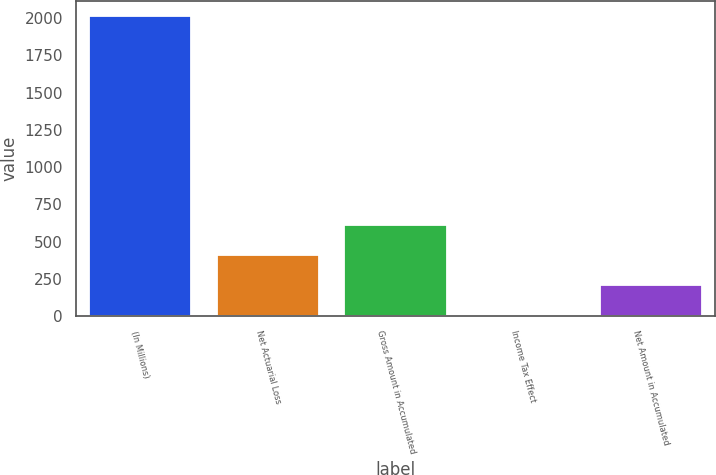Convert chart. <chart><loc_0><loc_0><loc_500><loc_500><bar_chart><fcel>(In Millions)<fcel>Net Actuarial Loss<fcel>Gross Amount in Accumulated<fcel>Income Tax Effect<fcel>Net Amount in Accumulated<nl><fcel>2016<fcel>408.56<fcel>609.49<fcel>6.7<fcel>207.63<nl></chart> 